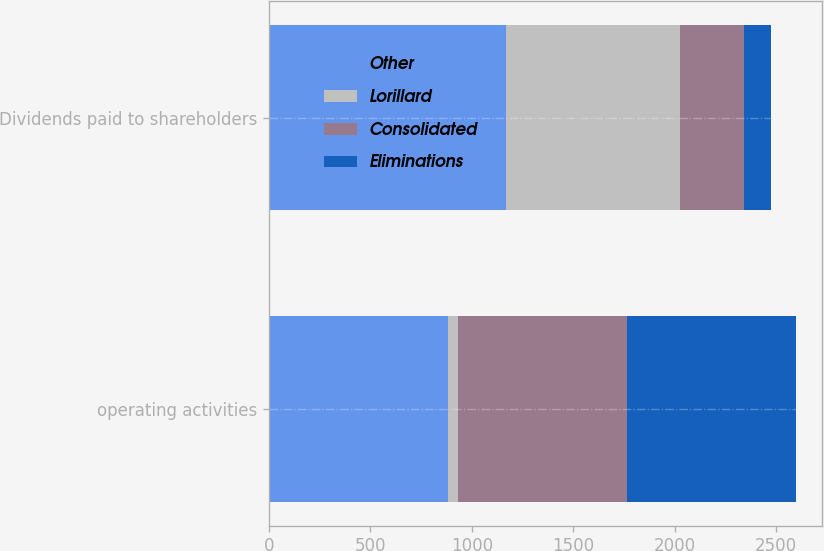Convert chart. <chart><loc_0><loc_0><loc_500><loc_500><stacked_bar_chart><ecel><fcel>operating activities<fcel>Dividends paid to shareholders<nl><fcel>Other<fcel>882<fcel>1170<nl><fcel>Lorillard<fcel>48<fcel>854<nl><fcel>Consolidated<fcel>834<fcel>316<nl><fcel>Eliminations<fcel>834<fcel>134<nl></chart> 